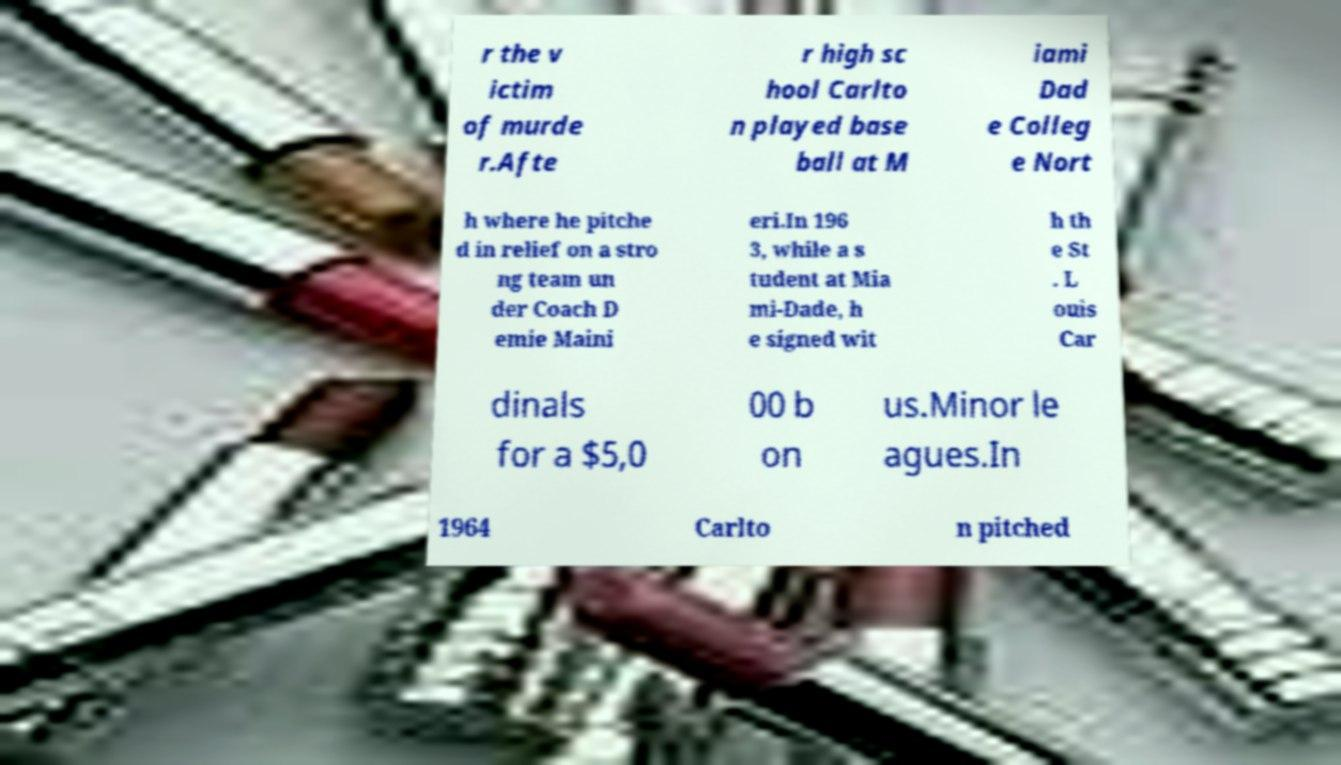I need the written content from this picture converted into text. Can you do that? r the v ictim of murde r.Afte r high sc hool Carlto n played base ball at M iami Dad e Colleg e Nort h where he pitche d in relief on a stro ng team un der Coach D emie Maini eri.In 196 3, while a s tudent at Mia mi-Dade, h e signed wit h th e St . L ouis Car dinals for a $5,0 00 b on us.Minor le agues.In 1964 Carlto n pitched 